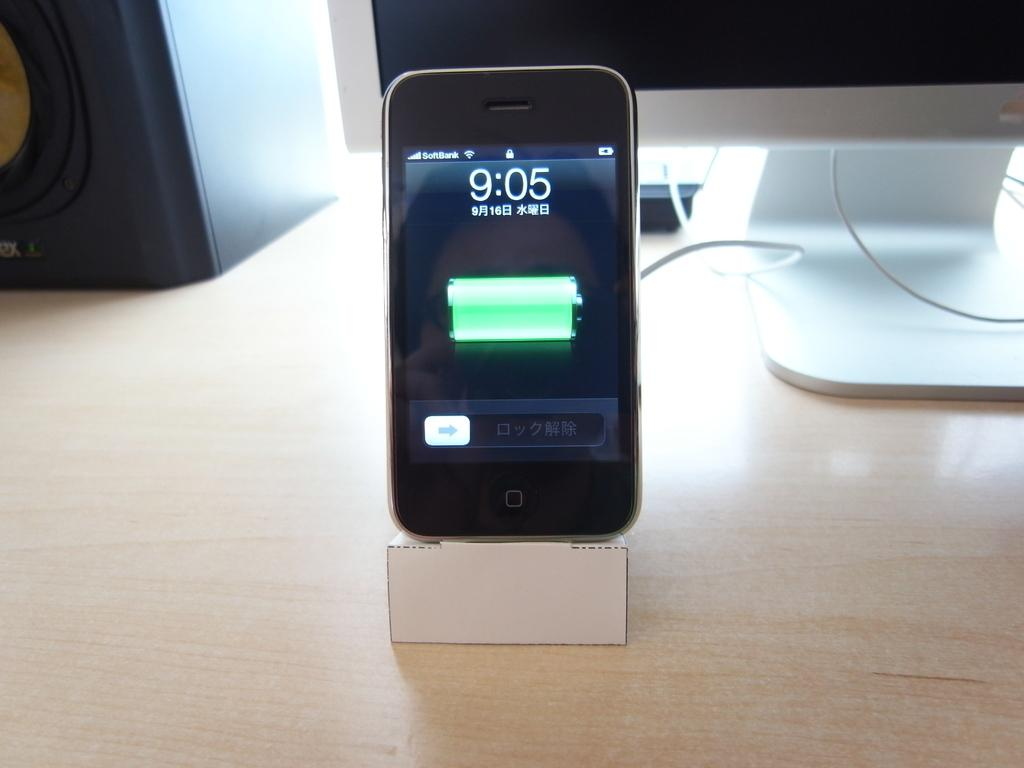<image>
Summarize the visual content of the image. An older model Apple iPhone displays a time of day of 9:05. 